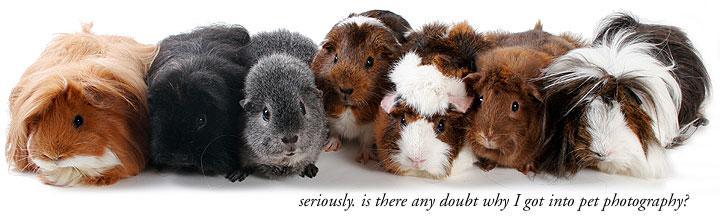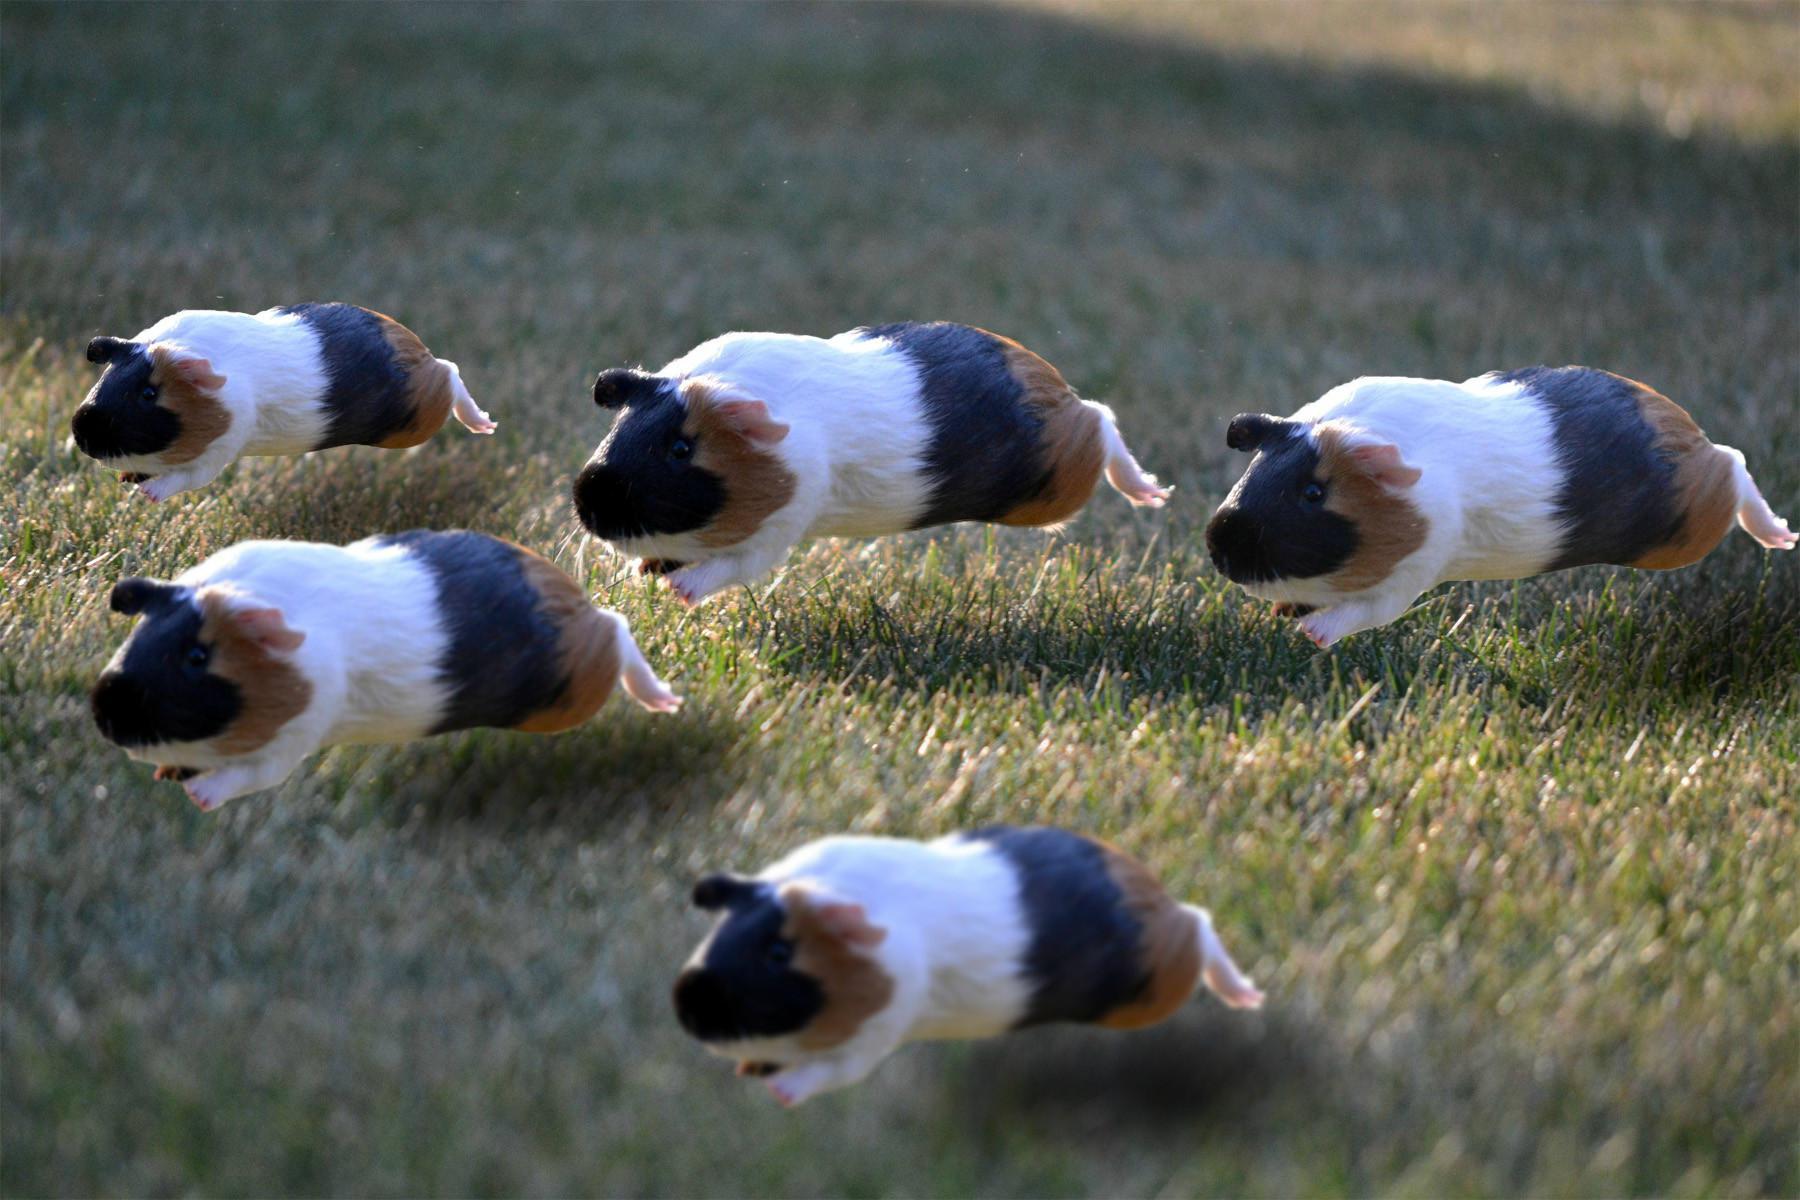The first image is the image on the left, the second image is the image on the right. Examine the images to the left and right. Is the description "One of the images shows multiple guinea pigs on green grass." accurate? Answer yes or no. Yes. The first image is the image on the left, the second image is the image on the right. Considering the images on both sides, is "An image features at least five guinea pigs on green grass, and each image contains multiple guinea pigs." valid? Answer yes or no. Yes. 